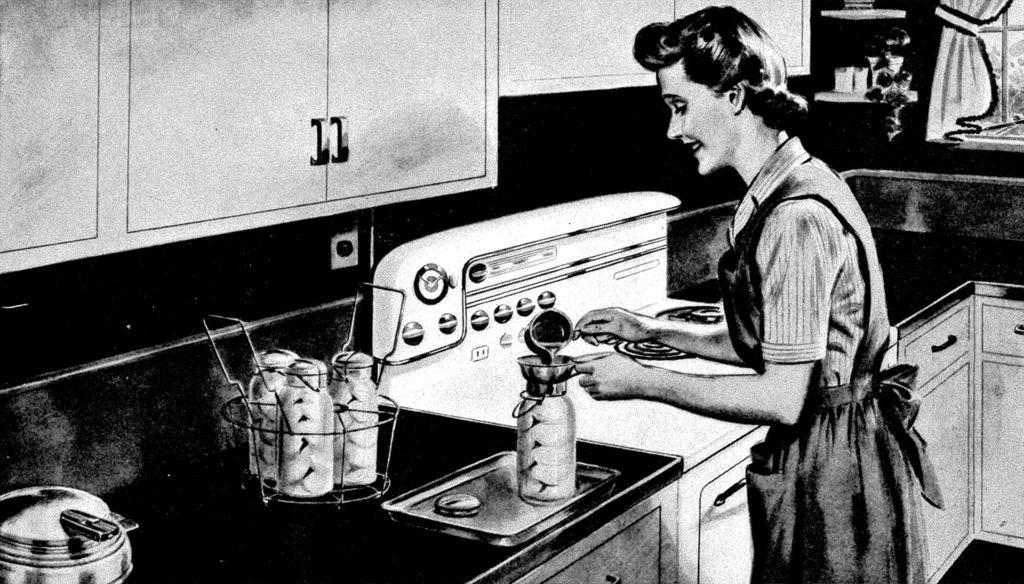In one or two sentences, can you explain what this image depicts? In the picture I can see drawing of a woman who is standing and holding some objects in hands. I can also see a kitchen table which has utensils and some other objects on it. Here I can see cupboards and a window. 